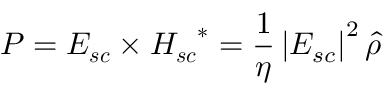Convert formula to latex. <formula><loc_0><loc_0><loc_500><loc_500>P = E _ { s c } \times H _ { s c } ^ { * } = \frac { 1 } { \eta } \left | E _ { s c } \right | ^ { 2 } \hat { \rho }</formula> 